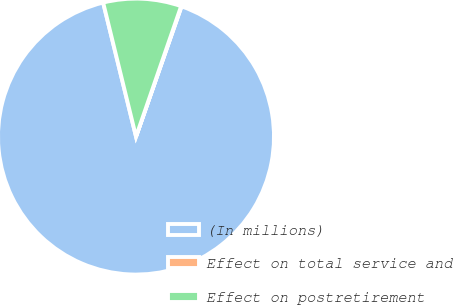<chart> <loc_0><loc_0><loc_500><loc_500><pie_chart><fcel>(In millions)<fcel>Effect on total service and<fcel>Effect on postretirement<nl><fcel>90.82%<fcel>0.05%<fcel>9.13%<nl></chart> 